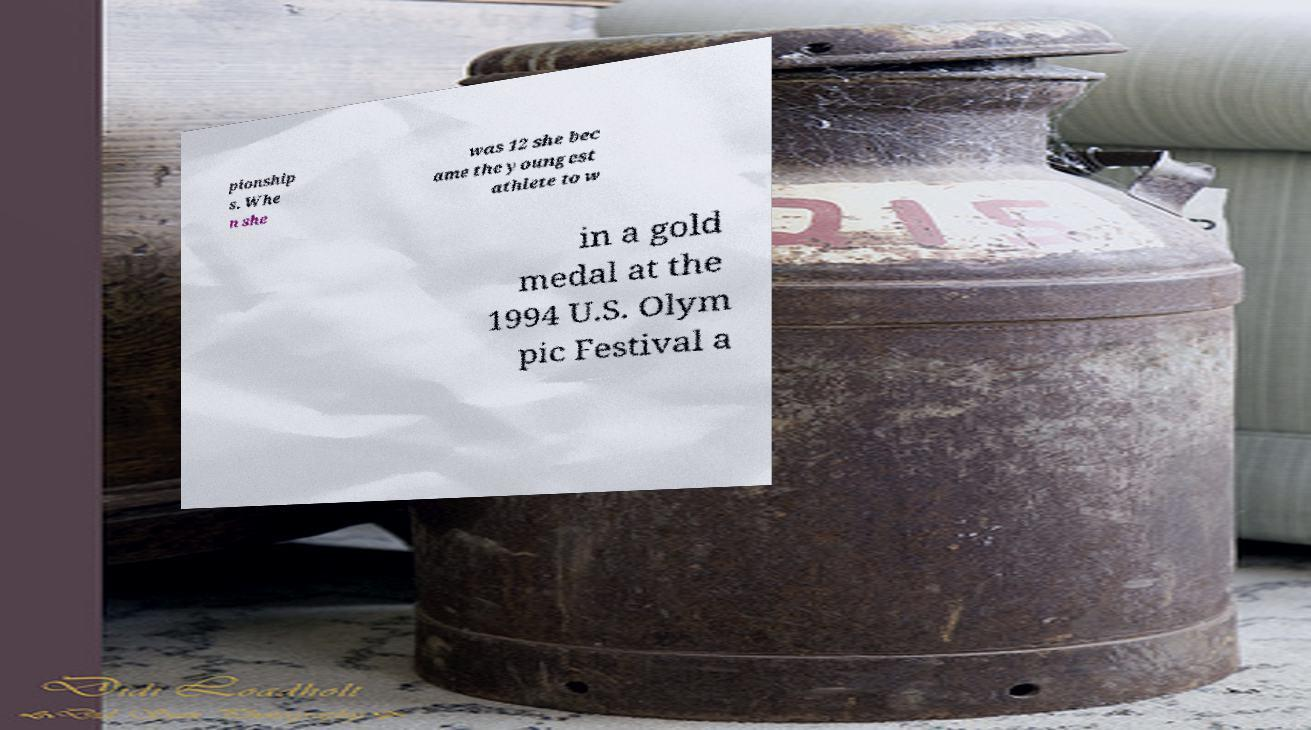Please read and relay the text visible in this image. What does it say? pionship s. Whe n she was 12 she bec ame the youngest athlete to w in a gold medal at the 1994 U.S. Olym pic Festival a 